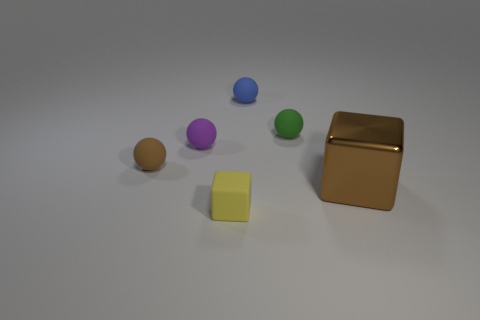Are the brown thing that is behind the large metal object and the small blue thing made of the same material?
Your answer should be very brief. Yes. Is the color of the big metal object the same as the small block?
Provide a short and direct response. No. There is a brown thing behind the large metallic block; is it the same shape as the brown object to the right of the tiny yellow object?
Your response must be concise. No. Is the small ball in front of the tiny purple rubber ball made of the same material as the brown object right of the tiny block?
Your answer should be very brief. No. There is a yellow block that is the same size as the purple thing; what is its material?
Provide a short and direct response. Rubber. What is the shape of the thing that is in front of the small purple sphere and right of the yellow cube?
Your response must be concise. Cube. What is the color of the matte cube that is the same size as the blue object?
Offer a terse response. Yellow. There is a rubber object that is right of the small blue matte ball; does it have the same size as the block left of the small green object?
Your answer should be very brief. Yes. There is a block in front of the block right of the tiny rubber sphere that is behind the green ball; how big is it?
Your answer should be very brief. Small. There is a tiny rubber object that is in front of the cube that is on the right side of the small matte block; what is its shape?
Provide a short and direct response. Cube. 